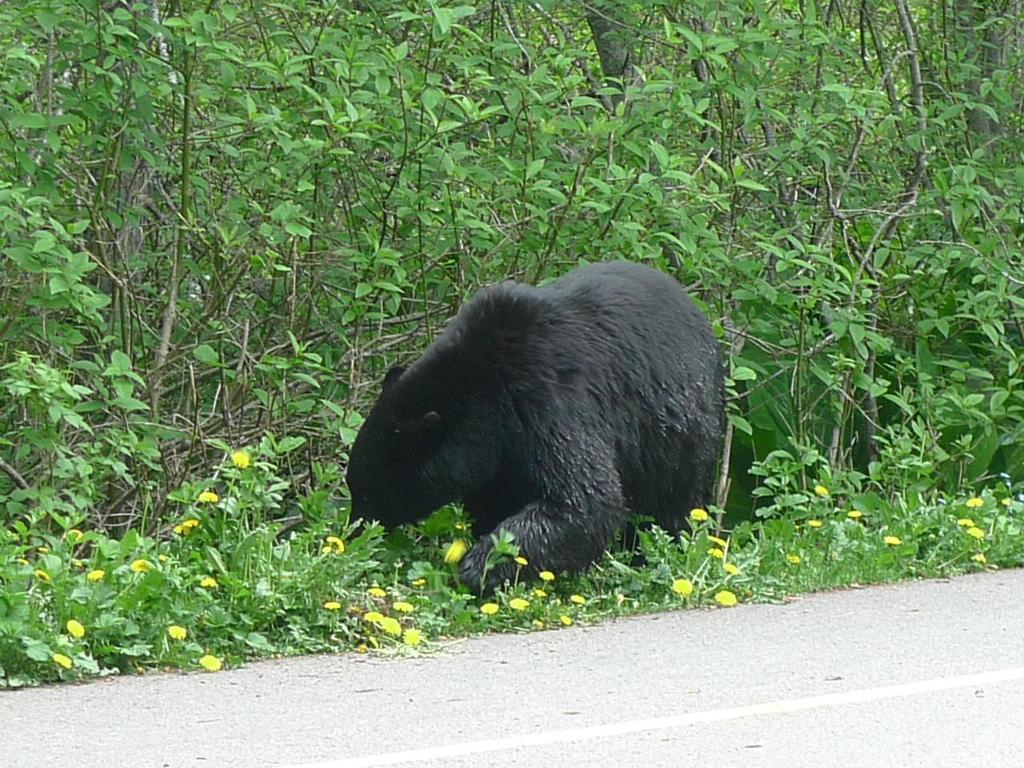What is the main feature of the image? There is a road in the image. What else can be seen in the image besides the road? There are flower plants and a bear in the image. What type of vegetation is present in the image? There are flower plants and trees in the image. What type of basin is visible in the image? There is no basin present in the image. What part of the flower plants can be seen in the image? The image does not focus on a specific part of the flower plants, but rather shows the entire plants. 